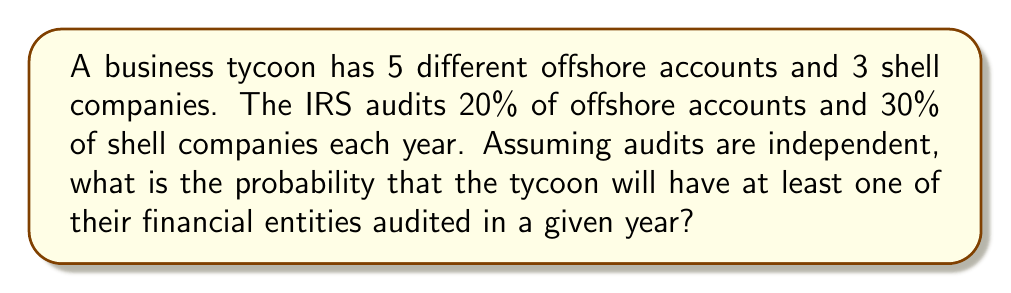Solve this math problem. Let's approach this step-by-step:

1) First, let's calculate the probability of an offshore account not being audited:
   $P(\text{offshore account not audited}) = 1 - 0.20 = 0.80$

2) The probability of a shell company not being audited:
   $P(\text{shell company not audited}) = 1 - 0.30 = 0.70$

3) For the tycoon to avoid all audits, all 5 offshore accounts AND all 3 shell companies must not be audited. Given that the audits are independent, we can multiply these probabilities:

   $P(\text{no audits}) = (0.80)^5 \times (0.70)^3$

4) Let's calculate this:
   $P(\text{no audits}) = 0.32768 \times 0.343 = 0.11239424$

5) The probability of at least one audit is the complement of the probability of no audits:

   $P(\text{at least one audit}) = 1 - P(\text{no audits})$
   $= 1 - 0.11239424$
   $= 0.88760576$

Thus, the probability of the tycoon having at least one of their financial entities audited is approximately 0.8876 or 88.76%.
Answer: $0.8876$ or $88.76\%$ 